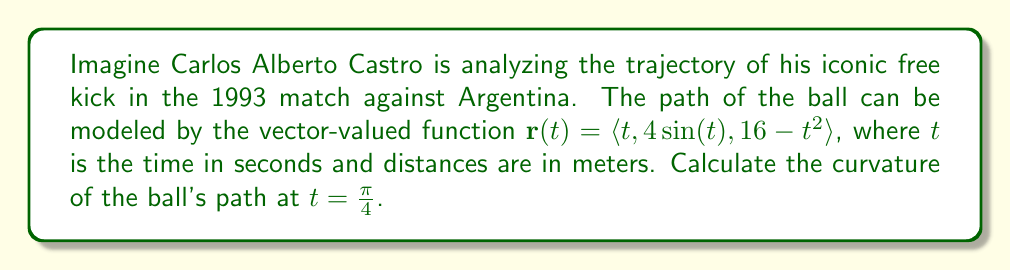Teach me how to tackle this problem. To find the curvature of the ball's path, we'll use the formula for curvature of a vector-valued function:

$$\kappa = \frac{|\mathbf{r}'(t) \times \mathbf{r}''(t)|}{|\mathbf{r}'(t)|^3}$$

Step 1: Calculate $\mathbf{r}'(t)$
$$\mathbf{r}'(t) = \langle 1, 4\cos(t), -2t \rangle$$

Step 2: Calculate $\mathbf{r}''(t)$
$$\mathbf{r}''(t) = \langle 0, -4\sin(t), -2 \rangle$$

Step 3: Evaluate $\mathbf{r}'(\frac{\pi}{4})$ and $\mathbf{r}''(\frac{\pi}{4})$
$$\mathbf{r}'(\frac{\pi}{4}) = \langle 1, 4\cos(\frac{\pi}{4}), -\frac{\pi}{2} \rangle = \langle 1, 2\sqrt{2}, -\frac{\pi}{2} \rangle$$
$$\mathbf{r}''(\frac{\pi}{4}) = \langle 0, -4\sin(\frac{\pi}{4}), -2 \rangle = \langle 0, -2\sqrt{2}, -2 \rangle$$

Step 4: Calculate $\mathbf{r}'(\frac{\pi}{4}) \times \mathbf{r}''(\frac{\pi}{4})$
$$\mathbf{r}'(\frac{\pi}{4}) \times \mathbf{r}''(\frac{\pi}{4}) = \begin{vmatrix}
\mathbf{i} & \mathbf{j} & \mathbf{k} \\
1 & 2\sqrt{2} & -\frac{\pi}{2} \\
0 & -2\sqrt{2} & -2
\end{vmatrix}$$

$$= \langle -4\sqrt{2} + \pi\sqrt{2}, 2, 2\sqrt{2} \rangle$$

Step 5: Calculate $|\mathbf{r}'(\frac{\pi}{4}) \times \mathbf{r}''(\frac{\pi}{4})|$
$$|\mathbf{r}'(\frac{\pi}{4}) \times \mathbf{r}''(\frac{\pi}{4})| = \sqrt{(-4\sqrt{2} + \pi\sqrt{2})^2 + 2^2 + (2\sqrt{2})^2}$$
$$= \sqrt{32 - 8\pi + \pi^2 + 4 + 8} = \sqrt{44 - 8\pi + \pi^2}$$

Step 6: Calculate $|\mathbf{r}'(\frac{\pi}{4})|$
$$|\mathbf{r}'(\frac{\pi}{4})| = \sqrt{1^2 + (2\sqrt{2})^2 + (-\frac{\pi}{2})^2} = \sqrt{1 + 8 + \frac{\pi^2}{4}} = \sqrt{\frac{\pi^2 + 36}{4}}$$

Step 7: Apply the curvature formula
$$\kappa = \frac{\sqrt{44 - 8\pi + \pi^2}}{(\sqrt{\frac{\pi^2 + 36}{4}})^3}$$
Answer: The curvature of the ball's path at $t=\frac{\pi}{4}$ is:

$$\kappa = \frac{\sqrt{44 - 8\pi + \pi^2}}{(\sqrt{\frac{\pi^2 + 36}{4}})^3}$$ 